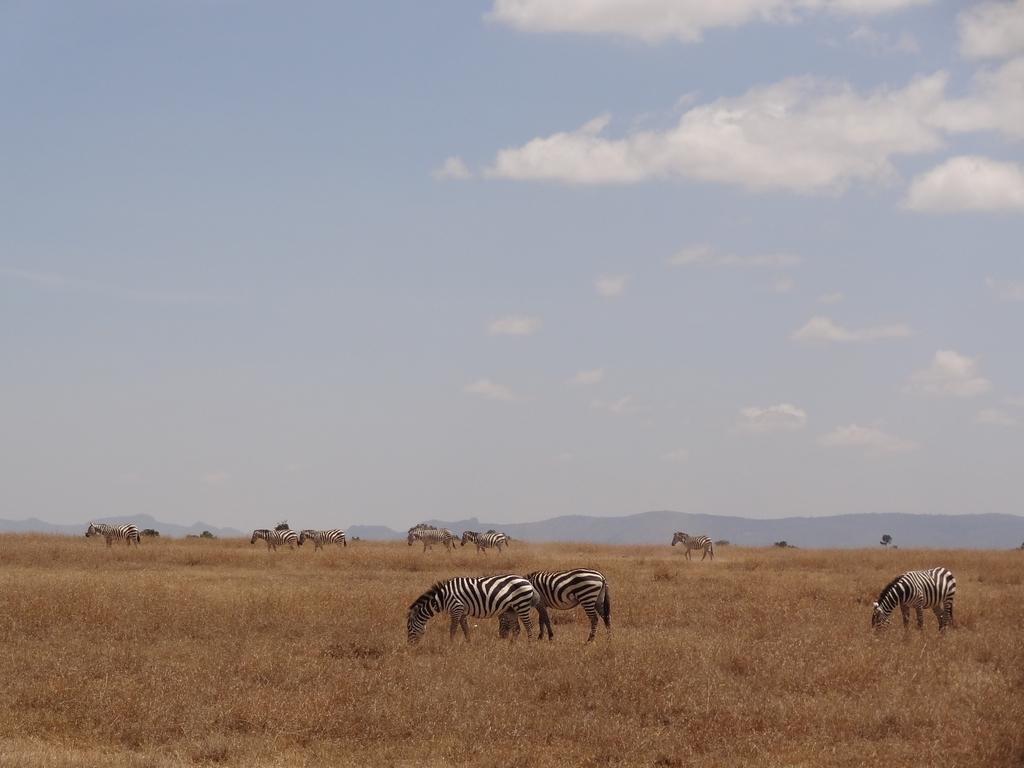Describe this image in one or two sentences. In this image I can see few zebras in white and black color. I can see the dry grass and mountains. The sky is in blue and white color. 